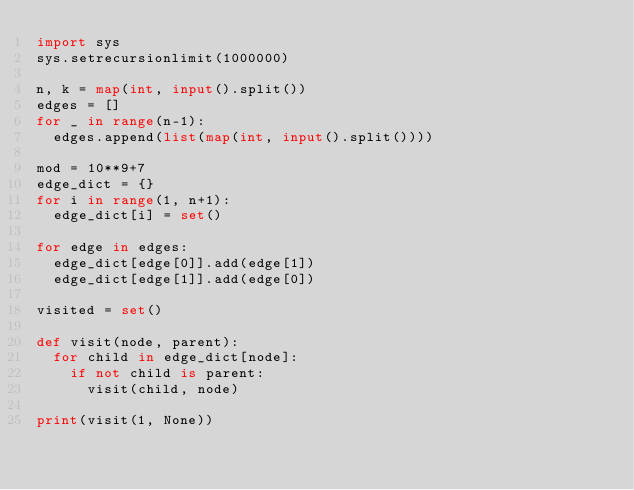Convert code to text. <code><loc_0><loc_0><loc_500><loc_500><_Python_>import sys
sys.setrecursionlimit(1000000)

n, k = map(int, input().split())
edges = []
for _ in range(n-1):
  edges.append(list(map(int, input().split())))

mod = 10**9+7
edge_dict = {}
for i in range(1, n+1):
  edge_dict[i] = set()

for edge in edges:
  edge_dict[edge[0]].add(edge[1])
  edge_dict[edge[1]].add(edge[0])

visited = set()

def visit(node, parent):
  for child in edge_dict[node]:
    if not child is parent:
      visit(child, node)

print(visit(1, None))</code> 